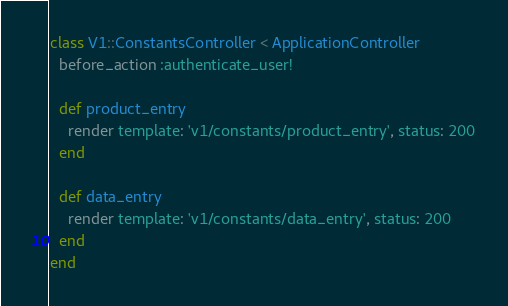Convert code to text. <code><loc_0><loc_0><loc_500><loc_500><_Ruby_>class V1::ConstantsController < ApplicationController
  before_action :authenticate_user!

  def product_entry
    render template: 'v1/constants/product_entry', status: 200
  end

  def data_entry
    render template: 'v1/constants/data_entry', status: 200
  end
end

</code> 